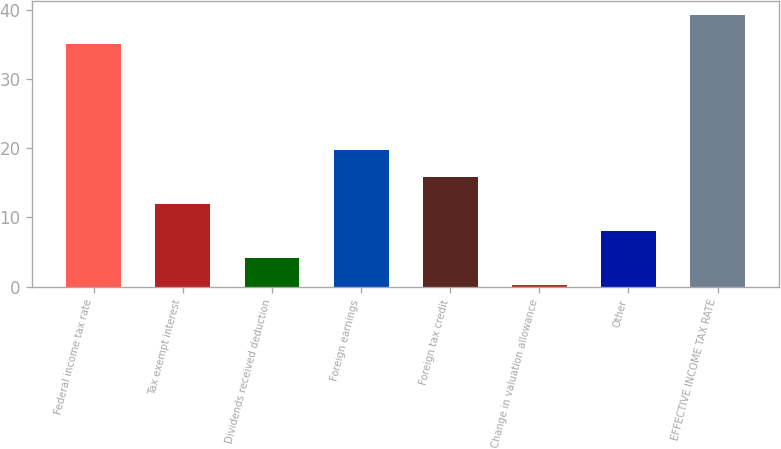Convert chart. <chart><loc_0><loc_0><loc_500><loc_500><bar_chart><fcel>Federal income tax rate<fcel>Tax exempt interest<fcel>Dividends received deduction<fcel>Foreign earnings<fcel>Foreign tax credit<fcel>Change in valuation allowance<fcel>Other<fcel>EFFECTIVE INCOME TAX RATE<nl><fcel>35<fcel>11.93<fcel>4.11<fcel>19.75<fcel>15.84<fcel>0.2<fcel>8.02<fcel>39.3<nl></chart> 